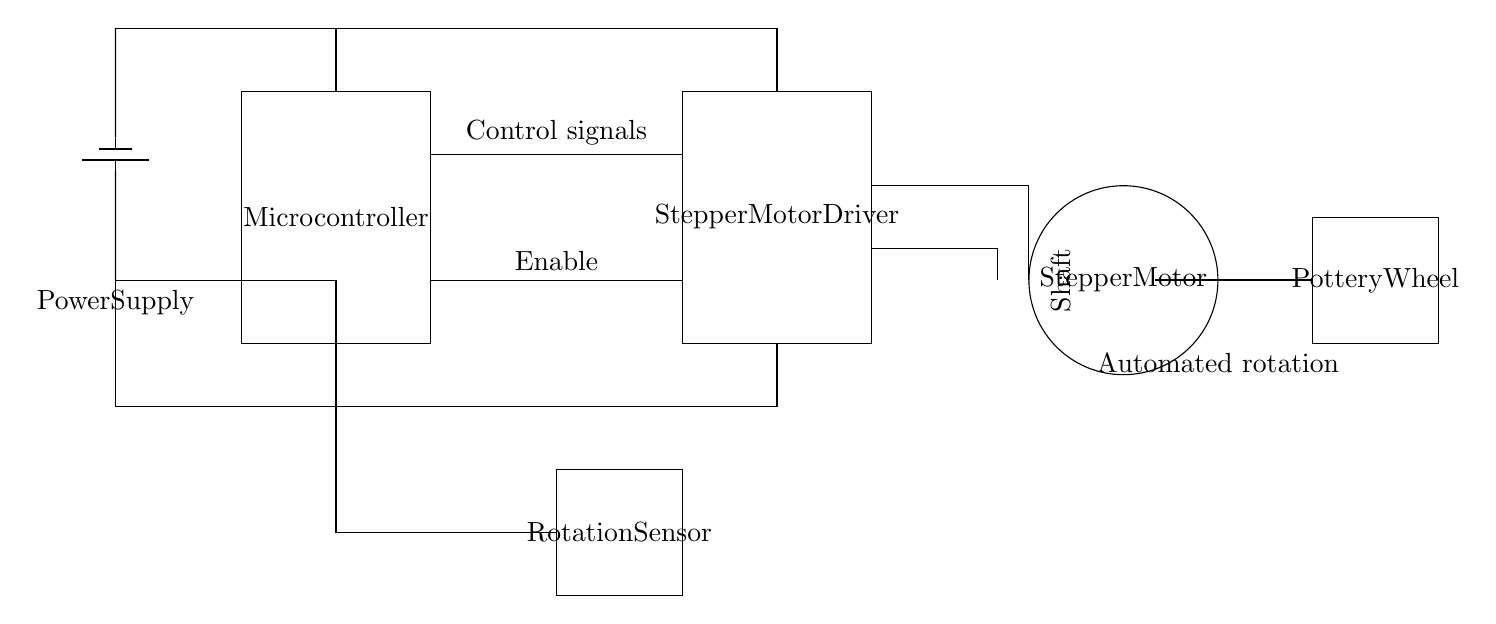What is the main component controlling the motor? The main component controlling the motor is the microcontroller, which sends control signals to the stepper motor driver.
Answer: Microcontroller What type of motor is used in this circuit? The circuit uses a stepper motor, as indicated in the labeling on the circle symbol in the diagram.
Answer: Stepper motor How many main parts are there in the circuit? The circuit contains four main parts: the microcontroller, stepper motor driver, stepper motor, and power supply.
Answer: Four What indicates the power supply voltage type in the diagram? The power supply is represented by a battery symbol, which typically indicates a DC voltage source.
Answer: Direct current What connects the microcontroller to the motor driver? Control signals connect the microcontroller to the motor driver, enabling it to drive the stepper motor according to the programmed commands.
Answer: Control signals Which component could enhance the motor's functionality by providing feedback? The rotation sensor can provide feedback regarding the motor's position and speed, allowing for more precise control.
Answer: Rotation sensor How is the power distributed in the circuit? The power supply connects to both the microcontroller and the stepper motor driver, showing a distribution of power to these components with appropriate voltage levels.
Answer: Power distribution 